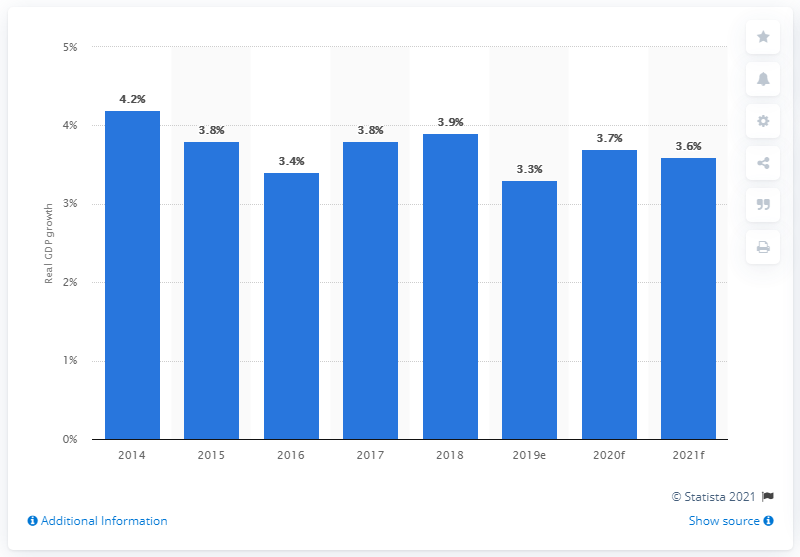List a handful of essential elements in this visual. The growth of Indonesia's agriculture sector in 2019 was estimated to be 3.3%. 